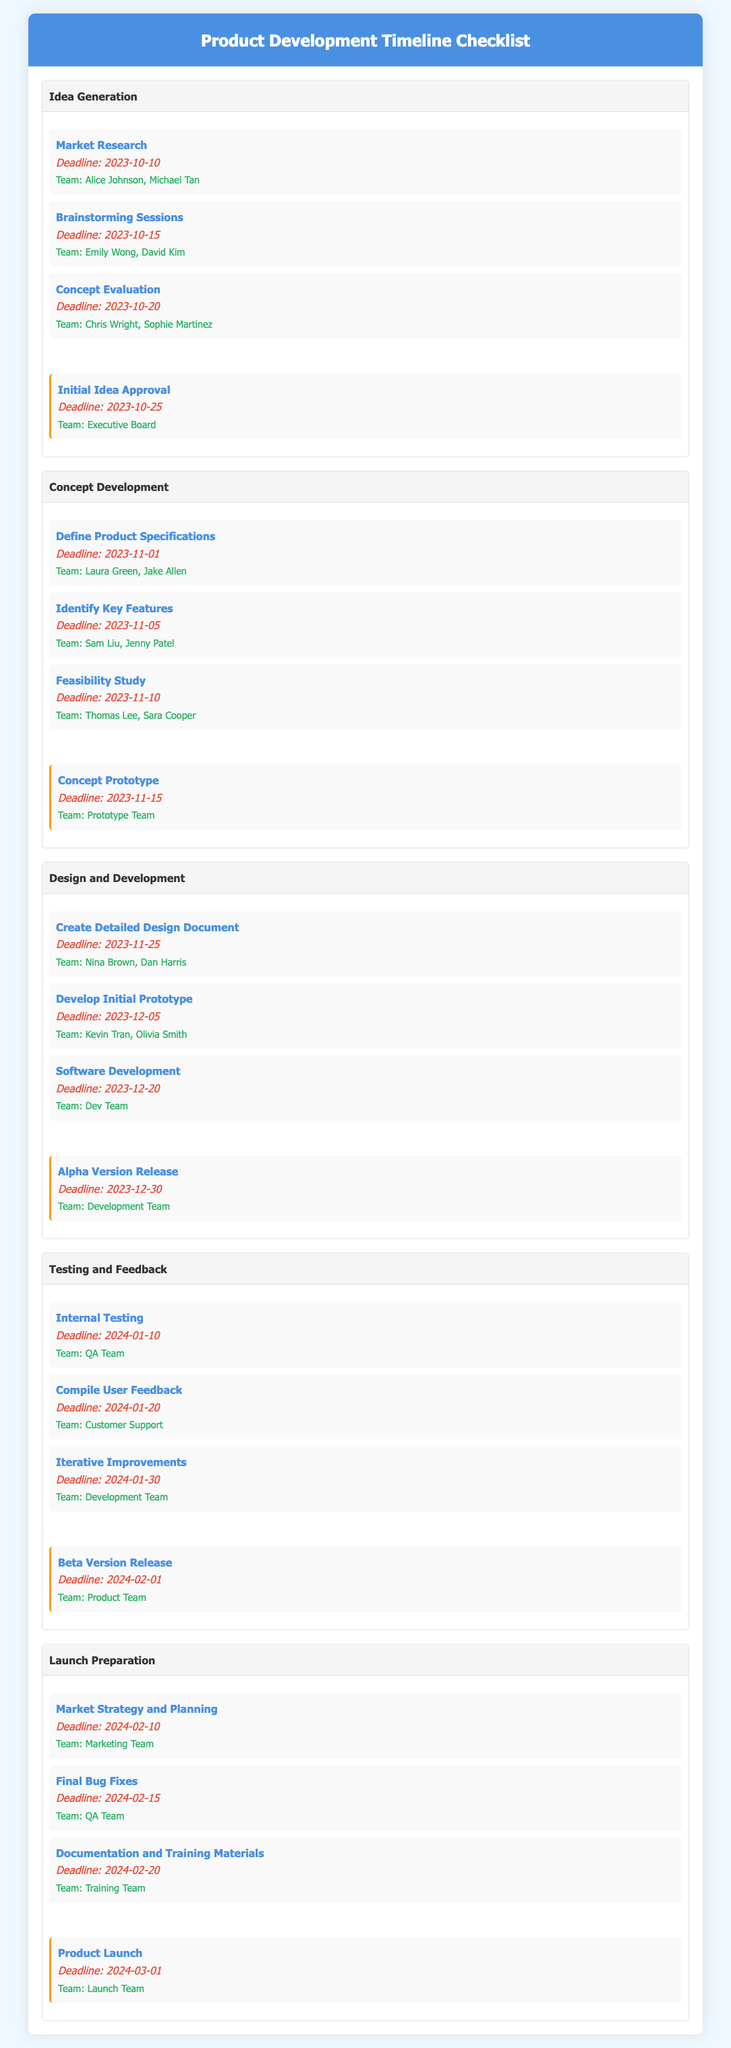What is the deadline for Market Research? The deadline for Market Research is specified in the document, which is October 10, 2023.
Answer: October 10, 2023 Who is responsible for the Beta Version Release milestone? The document indicates that the Product Team is responsible for the Beta Version Release milestone.
Answer: Product Team What task needs to be completed by February 20, 2024? The document states that "Documentation and Training Materials" must be completed by this date.
Answer: Documentation and Training Materials In which stage is the task "Develop Initial Prototype"? The task "Develop Initial Prototype" is listed under the "Design and Development" stage of the document.
Answer: Design and Development How many tasks are listed in the "Launch Preparation" stage? The document shows that there are three tasks in the "Launch Preparation" stage.
Answer: Three What is the deadline for the Concept Prototype milestone? The Concept Prototype milestone must be completed by the deadline specified in the document, which is November 15, 2023.
Answer: November 15, 2023 Which team members are responsible for the "Feasibility Study" task? The document lists Thomas Lee and Sara Cooper as the responsible team members for the "Feasibility Study" task.
Answer: Thomas Lee, Sara Cooper What is the last milestone mentioned in the checklist? The last milestone included in the document is the "Product Launch," which marks the end of the phases.
Answer: Product Launch 